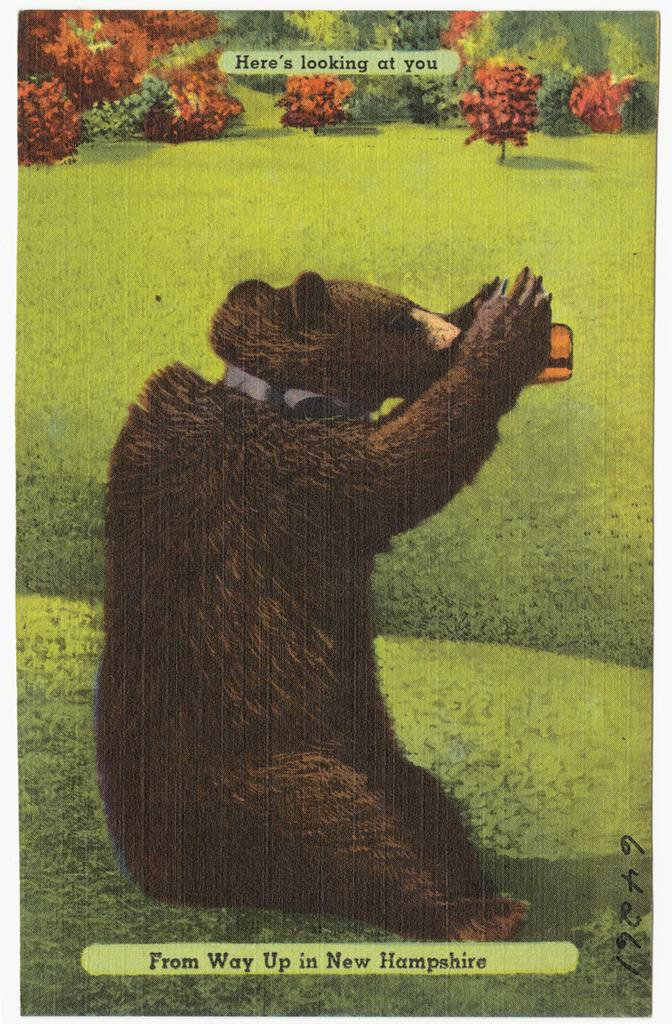What type of animal is in the image? There is an animal in the image, but its specific type cannot be determined from the provided facts. Can you describe the color of the animal? The animal is brown and black in color. What can be seen in the background of the image? There are plants and many trees in the background of the image. Is there any text present in the image? Yes, there is text written on the image. How many sticks are being used by the animal in the image? There is no mention of sticks or any interaction between the animal and sticks in the image. What type of bead is being used by the animal in the image? There is no mention of beads or any interaction between the animal and beads in the image. 